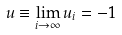Convert formula to latex. <formula><loc_0><loc_0><loc_500><loc_500>u \equiv \lim _ { i \rightarrow \infty } u _ { i } = - 1</formula> 